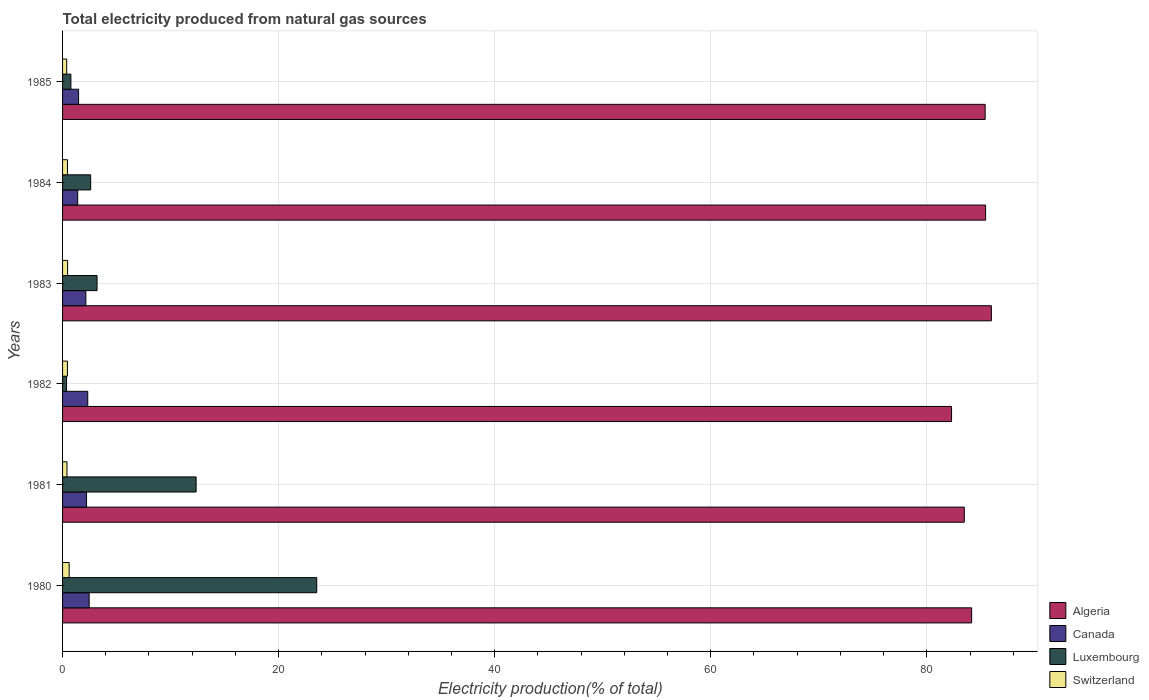How many different coloured bars are there?
Provide a short and direct response. 4. How many groups of bars are there?
Offer a very short reply. 6. Are the number of bars per tick equal to the number of legend labels?
Provide a short and direct response. Yes. Are the number of bars on each tick of the Y-axis equal?
Offer a terse response. Yes. How many bars are there on the 1st tick from the top?
Ensure brevity in your answer.  4. How many bars are there on the 4th tick from the bottom?
Your response must be concise. 4. What is the total electricity produced in Algeria in 1984?
Offer a terse response. 85.44. Across all years, what is the maximum total electricity produced in Canada?
Provide a short and direct response. 2.46. Across all years, what is the minimum total electricity produced in Switzerland?
Offer a very short reply. 0.38. What is the total total electricity produced in Switzerland in the graph?
Make the answer very short. 2.77. What is the difference between the total electricity produced in Luxembourg in 1980 and that in 1983?
Make the answer very short. 20.34. What is the difference between the total electricity produced in Luxembourg in 1985 and the total electricity produced in Switzerland in 1984?
Your response must be concise. 0.32. What is the average total electricity produced in Luxembourg per year?
Ensure brevity in your answer.  7.14. In the year 1980, what is the difference between the total electricity produced in Canada and total electricity produced in Switzerland?
Your answer should be compact. 1.85. In how many years, is the total electricity produced in Canada greater than 4 %?
Ensure brevity in your answer.  0. What is the ratio of the total electricity produced in Switzerland in 1980 to that in 1981?
Offer a terse response. 1.49. Is the difference between the total electricity produced in Canada in 1981 and 1982 greater than the difference between the total electricity produced in Switzerland in 1981 and 1982?
Your response must be concise. No. What is the difference between the highest and the second highest total electricity produced in Switzerland?
Offer a very short reply. 0.14. What is the difference between the highest and the lowest total electricity produced in Algeria?
Provide a succinct answer. 3.69. Is the sum of the total electricity produced in Canada in 1981 and 1984 greater than the maximum total electricity produced in Luxembourg across all years?
Keep it short and to the point. No. What does the 4th bar from the top in 1985 represents?
Your answer should be very brief. Algeria. How many bars are there?
Your answer should be very brief. 24. Does the graph contain any zero values?
Your answer should be compact. No. Where does the legend appear in the graph?
Give a very brief answer. Bottom right. How many legend labels are there?
Provide a short and direct response. 4. How are the legend labels stacked?
Give a very brief answer. Vertical. What is the title of the graph?
Offer a very short reply. Total electricity produced from natural gas sources. What is the Electricity production(% of total) in Algeria in 1980?
Your answer should be very brief. 84.15. What is the Electricity production(% of total) of Canada in 1980?
Offer a terse response. 2.46. What is the Electricity production(% of total) in Luxembourg in 1980?
Offer a terse response. 23.53. What is the Electricity production(% of total) in Switzerland in 1980?
Provide a succinct answer. 0.61. What is the Electricity production(% of total) of Algeria in 1981?
Your answer should be very brief. 83.47. What is the Electricity production(% of total) in Canada in 1981?
Ensure brevity in your answer.  2.22. What is the Electricity production(% of total) in Luxembourg in 1981?
Your answer should be compact. 12.36. What is the Electricity production(% of total) in Switzerland in 1981?
Ensure brevity in your answer.  0.41. What is the Electricity production(% of total) of Algeria in 1982?
Offer a terse response. 82.29. What is the Electricity production(% of total) in Canada in 1982?
Give a very brief answer. 2.33. What is the Electricity production(% of total) in Luxembourg in 1982?
Give a very brief answer. 0.37. What is the Electricity production(% of total) of Switzerland in 1982?
Your answer should be compact. 0.45. What is the Electricity production(% of total) of Algeria in 1983?
Your response must be concise. 85.98. What is the Electricity production(% of total) of Canada in 1983?
Keep it short and to the point. 2.16. What is the Electricity production(% of total) in Luxembourg in 1983?
Offer a very short reply. 3.19. What is the Electricity production(% of total) of Switzerland in 1983?
Provide a short and direct response. 0.47. What is the Electricity production(% of total) in Algeria in 1984?
Give a very brief answer. 85.44. What is the Electricity production(% of total) of Canada in 1984?
Your answer should be very brief. 1.4. What is the Electricity production(% of total) in Luxembourg in 1984?
Give a very brief answer. 2.6. What is the Electricity production(% of total) in Switzerland in 1984?
Your response must be concise. 0.45. What is the Electricity production(% of total) in Algeria in 1985?
Your response must be concise. 85.4. What is the Electricity production(% of total) in Canada in 1985?
Your answer should be compact. 1.48. What is the Electricity production(% of total) in Luxembourg in 1985?
Keep it short and to the point. 0.77. What is the Electricity production(% of total) of Switzerland in 1985?
Provide a succinct answer. 0.38. Across all years, what is the maximum Electricity production(% of total) in Algeria?
Give a very brief answer. 85.98. Across all years, what is the maximum Electricity production(% of total) in Canada?
Make the answer very short. 2.46. Across all years, what is the maximum Electricity production(% of total) in Luxembourg?
Provide a short and direct response. 23.53. Across all years, what is the maximum Electricity production(% of total) of Switzerland?
Make the answer very short. 0.61. Across all years, what is the minimum Electricity production(% of total) of Algeria?
Keep it short and to the point. 82.29. Across all years, what is the minimum Electricity production(% of total) in Canada?
Offer a terse response. 1.4. Across all years, what is the minimum Electricity production(% of total) of Luxembourg?
Ensure brevity in your answer.  0.37. Across all years, what is the minimum Electricity production(% of total) in Switzerland?
Your answer should be very brief. 0.38. What is the total Electricity production(% of total) of Algeria in the graph?
Ensure brevity in your answer.  506.73. What is the total Electricity production(% of total) of Canada in the graph?
Provide a short and direct response. 12.05. What is the total Electricity production(% of total) in Luxembourg in the graph?
Make the answer very short. 42.83. What is the total Electricity production(% of total) of Switzerland in the graph?
Ensure brevity in your answer.  2.77. What is the difference between the Electricity production(% of total) of Algeria in 1980 and that in 1981?
Your answer should be compact. 0.68. What is the difference between the Electricity production(% of total) of Canada in 1980 and that in 1981?
Keep it short and to the point. 0.24. What is the difference between the Electricity production(% of total) of Luxembourg in 1980 and that in 1981?
Your response must be concise. 11.17. What is the difference between the Electricity production(% of total) of Switzerland in 1980 and that in 1981?
Your answer should be very brief. 0.2. What is the difference between the Electricity production(% of total) in Algeria in 1980 and that in 1982?
Give a very brief answer. 1.86. What is the difference between the Electricity production(% of total) of Canada in 1980 and that in 1982?
Your answer should be very brief. 0.13. What is the difference between the Electricity production(% of total) in Luxembourg in 1980 and that in 1982?
Offer a very short reply. 23.16. What is the difference between the Electricity production(% of total) in Switzerland in 1980 and that in 1982?
Keep it short and to the point. 0.16. What is the difference between the Electricity production(% of total) in Algeria in 1980 and that in 1983?
Provide a short and direct response. -1.83. What is the difference between the Electricity production(% of total) in Canada in 1980 and that in 1983?
Provide a short and direct response. 0.31. What is the difference between the Electricity production(% of total) of Luxembourg in 1980 and that in 1983?
Make the answer very short. 20.34. What is the difference between the Electricity production(% of total) of Switzerland in 1980 and that in 1983?
Give a very brief answer. 0.14. What is the difference between the Electricity production(% of total) of Algeria in 1980 and that in 1984?
Make the answer very short. -1.29. What is the difference between the Electricity production(% of total) of Canada in 1980 and that in 1984?
Your response must be concise. 1.06. What is the difference between the Electricity production(% of total) of Luxembourg in 1980 and that in 1984?
Keep it short and to the point. 20.93. What is the difference between the Electricity production(% of total) of Switzerland in 1980 and that in 1984?
Provide a short and direct response. 0.16. What is the difference between the Electricity production(% of total) of Algeria in 1980 and that in 1985?
Your answer should be very brief. -1.25. What is the difference between the Electricity production(% of total) in Luxembourg in 1980 and that in 1985?
Your answer should be compact. 22.76. What is the difference between the Electricity production(% of total) in Switzerland in 1980 and that in 1985?
Offer a terse response. 0.23. What is the difference between the Electricity production(% of total) in Algeria in 1981 and that in 1982?
Keep it short and to the point. 1.18. What is the difference between the Electricity production(% of total) of Canada in 1981 and that in 1982?
Ensure brevity in your answer.  -0.11. What is the difference between the Electricity production(% of total) of Luxembourg in 1981 and that in 1982?
Your response must be concise. 11.99. What is the difference between the Electricity production(% of total) of Switzerland in 1981 and that in 1982?
Keep it short and to the point. -0.04. What is the difference between the Electricity production(% of total) in Algeria in 1981 and that in 1983?
Provide a short and direct response. -2.51. What is the difference between the Electricity production(% of total) of Canada in 1981 and that in 1983?
Keep it short and to the point. 0.06. What is the difference between the Electricity production(% of total) in Luxembourg in 1981 and that in 1983?
Give a very brief answer. 9.17. What is the difference between the Electricity production(% of total) in Switzerland in 1981 and that in 1983?
Give a very brief answer. -0.06. What is the difference between the Electricity production(% of total) in Algeria in 1981 and that in 1984?
Your response must be concise. -1.97. What is the difference between the Electricity production(% of total) in Canada in 1981 and that in 1984?
Keep it short and to the point. 0.82. What is the difference between the Electricity production(% of total) of Luxembourg in 1981 and that in 1984?
Make the answer very short. 9.76. What is the difference between the Electricity production(% of total) of Switzerland in 1981 and that in 1984?
Offer a terse response. -0.04. What is the difference between the Electricity production(% of total) of Algeria in 1981 and that in 1985?
Offer a terse response. -1.93. What is the difference between the Electricity production(% of total) in Canada in 1981 and that in 1985?
Keep it short and to the point. 0.74. What is the difference between the Electricity production(% of total) in Luxembourg in 1981 and that in 1985?
Provide a succinct answer. 11.59. What is the difference between the Electricity production(% of total) of Switzerland in 1981 and that in 1985?
Ensure brevity in your answer.  0.03. What is the difference between the Electricity production(% of total) in Algeria in 1982 and that in 1983?
Ensure brevity in your answer.  -3.69. What is the difference between the Electricity production(% of total) of Canada in 1982 and that in 1983?
Offer a very short reply. 0.18. What is the difference between the Electricity production(% of total) of Luxembourg in 1982 and that in 1983?
Ensure brevity in your answer.  -2.82. What is the difference between the Electricity production(% of total) in Switzerland in 1982 and that in 1983?
Your answer should be compact. -0.02. What is the difference between the Electricity production(% of total) of Algeria in 1982 and that in 1984?
Offer a very short reply. -3.15. What is the difference between the Electricity production(% of total) of Canada in 1982 and that in 1984?
Ensure brevity in your answer.  0.93. What is the difference between the Electricity production(% of total) in Luxembourg in 1982 and that in 1984?
Ensure brevity in your answer.  -2.23. What is the difference between the Electricity production(% of total) of Switzerland in 1982 and that in 1984?
Give a very brief answer. -0. What is the difference between the Electricity production(% of total) in Algeria in 1982 and that in 1985?
Make the answer very short. -3.11. What is the difference between the Electricity production(% of total) in Canada in 1982 and that in 1985?
Your answer should be compact. 0.85. What is the difference between the Electricity production(% of total) of Luxembourg in 1982 and that in 1985?
Your response must be concise. -0.4. What is the difference between the Electricity production(% of total) of Switzerland in 1982 and that in 1985?
Ensure brevity in your answer.  0.07. What is the difference between the Electricity production(% of total) of Algeria in 1983 and that in 1984?
Offer a very short reply. 0.53. What is the difference between the Electricity production(% of total) of Canada in 1983 and that in 1984?
Ensure brevity in your answer.  0.76. What is the difference between the Electricity production(% of total) in Luxembourg in 1983 and that in 1984?
Your response must be concise. 0.59. What is the difference between the Electricity production(% of total) in Switzerland in 1983 and that in 1984?
Provide a succinct answer. 0.02. What is the difference between the Electricity production(% of total) of Algeria in 1983 and that in 1985?
Your answer should be compact. 0.58. What is the difference between the Electricity production(% of total) of Canada in 1983 and that in 1985?
Give a very brief answer. 0.67. What is the difference between the Electricity production(% of total) in Luxembourg in 1983 and that in 1985?
Keep it short and to the point. 2.42. What is the difference between the Electricity production(% of total) in Switzerland in 1983 and that in 1985?
Your answer should be compact. 0.08. What is the difference between the Electricity production(% of total) in Algeria in 1984 and that in 1985?
Your answer should be compact. 0.04. What is the difference between the Electricity production(% of total) in Canada in 1984 and that in 1985?
Offer a very short reply. -0.08. What is the difference between the Electricity production(% of total) of Luxembourg in 1984 and that in 1985?
Offer a terse response. 1.83. What is the difference between the Electricity production(% of total) in Switzerland in 1984 and that in 1985?
Make the answer very short. 0.07. What is the difference between the Electricity production(% of total) of Algeria in 1980 and the Electricity production(% of total) of Canada in 1981?
Your answer should be compact. 81.93. What is the difference between the Electricity production(% of total) of Algeria in 1980 and the Electricity production(% of total) of Luxembourg in 1981?
Offer a very short reply. 71.79. What is the difference between the Electricity production(% of total) in Algeria in 1980 and the Electricity production(% of total) in Switzerland in 1981?
Offer a terse response. 83.74. What is the difference between the Electricity production(% of total) of Canada in 1980 and the Electricity production(% of total) of Luxembourg in 1981?
Your answer should be compact. -9.9. What is the difference between the Electricity production(% of total) of Canada in 1980 and the Electricity production(% of total) of Switzerland in 1981?
Provide a short and direct response. 2.05. What is the difference between the Electricity production(% of total) in Luxembourg in 1980 and the Electricity production(% of total) in Switzerland in 1981?
Offer a very short reply. 23.12. What is the difference between the Electricity production(% of total) in Algeria in 1980 and the Electricity production(% of total) in Canada in 1982?
Your answer should be compact. 81.82. What is the difference between the Electricity production(% of total) in Algeria in 1980 and the Electricity production(% of total) in Luxembourg in 1982?
Offer a very short reply. 83.78. What is the difference between the Electricity production(% of total) in Algeria in 1980 and the Electricity production(% of total) in Switzerland in 1982?
Keep it short and to the point. 83.7. What is the difference between the Electricity production(% of total) of Canada in 1980 and the Electricity production(% of total) of Luxembourg in 1982?
Ensure brevity in your answer.  2.09. What is the difference between the Electricity production(% of total) in Canada in 1980 and the Electricity production(% of total) in Switzerland in 1982?
Your answer should be very brief. 2.01. What is the difference between the Electricity production(% of total) of Luxembourg in 1980 and the Electricity production(% of total) of Switzerland in 1982?
Keep it short and to the point. 23.08. What is the difference between the Electricity production(% of total) in Algeria in 1980 and the Electricity production(% of total) in Canada in 1983?
Your response must be concise. 81.99. What is the difference between the Electricity production(% of total) of Algeria in 1980 and the Electricity production(% of total) of Luxembourg in 1983?
Make the answer very short. 80.96. What is the difference between the Electricity production(% of total) in Algeria in 1980 and the Electricity production(% of total) in Switzerland in 1983?
Give a very brief answer. 83.68. What is the difference between the Electricity production(% of total) in Canada in 1980 and the Electricity production(% of total) in Luxembourg in 1983?
Provide a succinct answer. -0.73. What is the difference between the Electricity production(% of total) of Canada in 1980 and the Electricity production(% of total) of Switzerland in 1983?
Ensure brevity in your answer.  2. What is the difference between the Electricity production(% of total) in Luxembourg in 1980 and the Electricity production(% of total) in Switzerland in 1983?
Ensure brevity in your answer.  23.06. What is the difference between the Electricity production(% of total) in Algeria in 1980 and the Electricity production(% of total) in Canada in 1984?
Keep it short and to the point. 82.75. What is the difference between the Electricity production(% of total) of Algeria in 1980 and the Electricity production(% of total) of Luxembourg in 1984?
Offer a very short reply. 81.55. What is the difference between the Electricity production(% of total) in Algeria in 1980 and the Electricity production(% of total) in Switzerland in 1984?
Your response must be concise. 83.7. What is the difference between the Electricity production(% of total) of Canada in 1980 and the Electricity production(% of total) of Luxembourg in 1984?
Your response must be concise. -0.14. What is the difference between the Electricity production(% of total) of Canada in 1980 and the Electricity production(% of total) of Switzerland in 1984?
Offer a terse response. 2.01. What is the difference between the Electricity production(% of total) in Luxembourg in 1980 and the Electricity production(% of total) in Switzerland in 1984?
Your answer should be very brief. 23.08. What is the difference between the Electricity production(% of total) of Algeria in 1980 and the Electricity production(% of total) of Canada in 1985?
Keep it short and to the point. 82.67. What is the difference between the Electricity production(% of total) of Algeria in 1980 and the Electricity production(% of total) of Luxembourg in 1985?
Your answer should be compact. 83.38. What is the difference between the Electricity production(% of total) of Algeria in 1980 and the Electricity production(% of total) of Switzerland in 1985?
Give a very brief answer. 83.77. What is the difference between the Electricity production(% of total) in Canada in 1980 and the Electricity production(% of total) in Luxembourg in 1985?
Keep it short and to the point. 1.69. What is the difference between the Electricity production(% of total) in Canada in 1980 and the Electricity production(% of total) in Switzerland in 1985?
Provide a succinct answer. 2.08. What is the difference between the Electricity production(% of total) in Luxembourg in 1980 and the Electricity production(% of total) in Switzerland in 1985?
Offer a very short reply. 23.15. What is the difference between the Electricity production(% of total) in Algeria in 1981 and the Electricity production(% of total) in Canada in 1982?
Your answer should be very brief. 81.14. What is the difference between the Electricity production(% of total) in Algeria in 1981 and the Electricity production(% of total) in Luxembourg in 1982?
Give a very brief answer. 83.1. What is the difference between the Electricity production(% of total) in Algeria in 1981 and the Electricity production(% of total) in Switzerland in 1982?
Offer a very short reply. 83.02. What is the difference between the Electricity production(% of total) in Canada in 1981 and the Electricity production(% of total) in Luxembourg in 1982?
Ensure brevity in your answer.  1.85. What is the difference between the Electricity production(% of total) in Canada in 1981 and the Electricity production(% of total) in Switzerland in 1982?
Provide a short and direct response. 1.77. What is the difference between the Electricity production(% of total) in Luxembourg in 1981 and the Electricity production(% of total) in Switzerland in 1982?
Make the answer very short. 11.91. What is the difference between the Electricity production(% of total) of Algeria in 1981 and the Electricity production(% of total) of Canada in 1983?
Your response must be concise. 81.31. What is the difference between the Electricity production(% of total) of Algeria in 1981 and the Electricity production(% of total) of Luxembourg in 1983?
Give a very brief answer. 80.28. What is the difference between the Electricity production(% of total) of Algeria in 1981 and the Electricity production(% of total) of Switzerland in 1983?
Your answer should be very brief. 83. What is the difference between the Electricity production(% of total) of Canada in 1981 and the Electricity production(% of total) of Luxembourg in 1983?
Offer a terse response. -0.97. What is the difference between the Electricity production(% of total) of Canada in 1981 and the Electricity production(% of total) of Switzerland in 1983?
Ensure brevity in your answer.  1.75. What is the difference between the Electricity production(% of total) of Luxembourg in 1981 and the Electricity production(% of total) of Switzerland in 1983?
Ensure brevity in your answer.  11.9. What is the difference between the Electricity production(% of total) in Algeria in 1981 and the Electricity production(% of total) in Canada in 1984?
Your answer should be very brief. 82.07. What is the difference between the Electricity production(% of total) in Algeria in 1981 and the Electricity production(% of total) in Luxembourg in 1984?
Your answer should be compact. 80.87. What is the difference between the Electricity production(% of total) in Algeria in 1981 and the Electricity production(% of total) in Switzerland in 1984?
Offer a very short reply. 83.02. What is the difference between the Electricity production(% of total) of Canada in 1981 and the Electricity production(% of total) of Luxembourg in 1984?
Provide a short and direct response. -0.38. What is the difference between the Electricity production(% of total) in Canada in 1981 and the Electricity production(% of total) in Switzerland in 1984?
Your answer should be compact. 1.77. What is the difference between the Electricity production(% of total) of Luxembourg in 1981 and the Electricity production(% of total) of Switzerland in 1984?
Your answer should be compact. 11.91. What is the difference between the Electricity production(% of total) in Algeria in 1981 and the Electricity production(% of total) in Canada in 1985?
Offer a very short reply. 81.98. What is the difference between the Electricity production(% of total) in Algeria in 1981 and the Electricity production(% of total) in Luxembourg in 1985?
Give a very brief answer. 82.7. What is the difference between the Electricity production(% of total) of Algeria in 1981 and the Electricity production(% of total) of Switzerland in 1985?
Your response must be concise. 83.08. What is the difference between the Electricity production(% of total) of Canada in 1981 and the Electricity production(% of total) of Luxembourg in 1985?
Make the answer very short. 1.45. What is the difference between the Electricity production(% of total) of Canada in 1981 and the Electricity production(% of total) of Switzerland in 1985?
Give a very brief answer. 1.84. What is the difference between the Electricity production(% of total) in Luxembourg in 1981 and the Electricity production(% of total) in Switzerland in 1985?
Your response must be concise. 11.98. What is the difference between the Electricity production(% of total) of Algeria in 1982 and the Electricity production(% of total) of Canada in 1983?
Your answer should be very brief. 80.13. What is the difference between the Electricity production(% of total) of Algeria in 1982 and the Electricity production(% of total) of Luxembourg in 1983?
Offer a very short reply. 79.1. What is the difference between the Electricity production(% of total) of Algeria in 1982 and the Electricity production(% of total) of Switzerland in 1983?
Ensure brevity in your answer.  81.82. What is the difference between the Electricity production(% of total) in Canada in 1982 and the Electricity production(% of total) in Luxembourg in 1983?
Give a very brief answer. -0.86. What is the difference between the Electricity production(% of total) in Canada in 1982 and the Electricity production(% of total) in Switzerland in 1983?
Provide a short and direct response. 1.86. What is the difference between the Electricity production(% of total) in Luxembourg in 1982 and the Electricity production(% of total) in Switzerland in 1983?
Provide a succinct answer. -0.1. What is the difference between the Electricity production(% of total) of Algeria in 1982 and the Electricity production(% of total) of Canada in 1984?
Offer a terse response. 80.89. What is the difference between the Electricity production(% of total) of Algeria in 1982 and the Electricity production(% of total) of Luxembourg in 1984?
Make the answer very short. 79.69. What is the difference between the Electricity production(% of total) in Algeria in 1982 and the Electricity production(% of total) in Switzerland in 1984?
Your answer should be very brief. 81.84. What is the difference between the Electricity production(% of total) of Canada in 1982 and the Electricity production(% of total) of Luxembourg in 1984?
Your response must be concise. -0.27. What is the difference between the Electricity production(% of total) of Canada in 1982 and the Electricity production(% of total) of Switzerland in 1984?
Offer a terse response. 1.88. What is the difference between the Electricity production(% of total) in Luxembourg in 1982 and the Electricity production(% of total) in Switzerland in 1984?
Make the answer very short. -0.08. What is the difference between the Electricity production(% of total) in Algeria in 1982 and the Electricity production(% of total) in Canada in 1985?
Your answer should be compact. 80.81. What is the difference between the Electricity production(% of total) in Algeria in 1982 and the Electricity production(% of total) in Luxembourg in 1985?
Ensure brevity in your answer.  81.52. What is the difference between the Electricity production(% of total) of Algeria in 1982 and the Electricity production(% of total) of Switzerland in 1985?
Give a very brief answer. 81.91. What is the difference between the Electricity production(% of total) of Canada in 1982 and the Electricity production(% of total) of Luxembourg in 1985?
Provide a succinct answer. 1.56. What is the difference between the Electricity production(% of total) of Canada in 1982 and the Electricity production(% of total) of Switzerland in 1985?
Provide a succinct answer. 1.95. What is the difference between the Electricity production(% of total) of Luxembourg in 1982 and the Electricity production(% of total) of Switzerland in 1985?
Provide a succinct answer. -0.01. What is the difference between the Electricity production(% of total) in Algeria in 1983 and the Electricity production(% of total) in Canada in 1984?
Your answer should be very brief. 84.58. What is the difference between the Electricity production(% of total) of Algeria in 1983 and the Electricity production(% of total) of Luxembourg in 1984?
Make the answer very short. 83.37. What is the difference between the Electricity production(% of total) in Algeria in 1983 and the Electricity production(% of total) in Switzerland in 1984?
Give a very brief answer. 85.52. What is the difference between the Electricity production(% of total) of Canada in 1983 and the Electricity production(% of total) of Luxembourg in 1984?
Offer a very short reply. -0.45. What is the difference between the Electricity production(% of total) in Canada in 1983 and the Electricity production(% of total) in Switzerland in 1984?
Give a very brief answer. 1.7. What is the difference between the Electricity production(% of total) of Luxembourg in 1983 and the Electricity production(% of total) of Switzerland in 1984?
Give a very brief answer. 2.74. What is the difference between the Electricity production(% of total) of Algeria in 1983 and the Electricity production(% of total) of Canada in 1985?
Keep it short and to the point. 84.49. What is the difference between the Electricity production(% of total) of Algeria in 1983 and the Electricity production(% of total) of Luxembourg in 1985?
Ensure brevity in your answer.  85.2. What is the difference between the Electricity production(% of total) in Algeria in 1983 and the Electricity production(% of total) in Switzerland in 1985?
Provide a succinct answer. 85.59. What is the difference between the Electricity production(% of total) of Canada in 1983 and the Electricity production(% of total) of Luxembourg in 1985?
Offer a very short reply. 1.39. What is the difference between the Electricity production(% of total) of Canada in 1983 and the Electricity production(% of total) of Switzerland in 1985?
Your response must be concise. 1.77. What is the difference between the Electricity production(% of total) of Luxembourg in 1983 and the Electricity production(% of total) of Switzerland in 1985?
Your answer should be very brief. 2.81. What is the difference between the Electricity production(% of total) of Algeria in 1984 and the Electricity production(% of total) of Canada in 1985?
Offer a terse response. 83.96. What is the difference between the Electricity production(% of total) of Algeria in 1984 and the Electricity production(% of total) of Luxembourg in 1985?
Provide a succinct answer. 84.67. What is the difference between the Electricity production(% of total) in Algeria in 1984 and the Electricity production(% of total) in Switzerland in 1985?
Give a very brief answer. 85.06. What is the difference between the Electricity production(% of total) of Canada in 1984 and the Electricity production(% of total) of Luxembourg in 1985?
Keep it short and to the point. 0.63. What is the difference between the Electricity production(% of total) of Canada in 1984 and the Electricity production(% of total) of Switzerland in 1985?
Your response must be concise. 1.02. What is the difference between the Electricity production(% of total) in Luxembourg in 1984 and the Electricity production(% of total) in Switzerland in 1985?
Ensure brevity in your answer.  2.22. What is the average Electricity production(% of total) of Algeria per year?
Your response must be concise. 84.45. What is the average Electricity production(% of total) of Canada per year?
Offer a terse response. 2.01. What is the average Electricity production(% of total) in Luxembourg per year?
Ensure brevity in your answer.  7.14. What is the average Electricity production(% of total) of Switzerland per year?
Your answer should be compact. 0.46. In the year 1980, what is the difference between the Electricity production(% of total) of Algeria and Electricity production(% of total) of Canada?
Your answer should be compact. 81.69. In the year 1980, what is the difference between the Electricity production(% of total) in Algeria and Electricity production(% of total) in Luxembourg?
Keep it short and to the point. 60.62. In the year 1980, what is the difference between the Electricity production(% of total) in Algeria and Electricity production(% of total) in Switzerland?
Offer a very short reply. 83.54. In the year 1980, what is the difference between the Electricity production(% of total) in Canada and Electricity production(% of total) in Luxembourg?
Your response must be concise. -21.07. In the year 1980, what is the difference between the Electricity production(% of total) in Canada and Electricity production(% of total) in Switzerland?
Your response must be concise. 1.85. In the year 1980, what is the difference between the Electricity production(% of total) of Luxembourg and Electricity production(% of total) of Switzerland?
Your answer should be very brief. 22.92. In the year 1981, what is the difference between the Electricity production(% of total) in Algeria and Electricity production(% of total) in Canada?
Make the answer very short. 81.25. In the year 1981, what is the difference between the Electricity production(% of total) of Algeria and Electricity production(% of total) of Luxembourg?
Your answer should be very brief. 71.11. In the year 1981, what is the difference between the Electricity production(% of total) of Algeria and Electricity production(% of total) of Switzerland?
Give a very brief answer. 83.06. In the year 1981, what is the difference between the Electricity production(% of total) in Canada and Electricity production(% of total) in Luxembourg?
Your answer should be very brief. -10.14. In the year 1981, what is the difference between the Electricity production(% of total) in Canada and Electricity production(% of total) in Switzerland?
Ensure brevity in your answer.  1.81. In the year 1981, what is the difference between the Electricity production(% of total) in Luxembourg and Electricity production(% of total) in Switzerland?
Make the answer very short. 11.95. In the year 1982, what is the difference between the Electricity production(% of total) of Algeria and Electricity production(% of total) of Canada?
Provide a succinct answer. 79.96. In the year 1982, what is the difference between the Electricity production(% of total) in Algeria and Electricity production(% of total) in Luxembourg?
Give a very brief answer. 81.92. In the year 1982, what is the difference between the Electricity production(% of total) of Algeria and Electricity production(% of total) of Switzerland?
Ensure brevity in your answer.  81.84. In the year 1982, what is the difference between the Electricity production(% of total) of Canada and Electricity production(% of total) of Luxembourg?
Keep it short and to the point. 1.96. In the year 1982, what is the difference between the Electricity production(% of total) of Canada and Electricity production(% of total) of Switzerland?
Your answer should be very brief. 1.88. In the year 1982, what is the difference between the Electricity production(% of total) of Luxembourg and Electricity production(% of total) of Switzerland?
Give a very brief answer. -0.08. In the year 1983, what is the difference between the Electricity production(% of total) of Algeria and Electricity production(% of total) of Canada?
Ensure brevity in your answer.  83.82. In the year 1983, what is the difference between the Electricity production(% of total) in Algeria and Electricity production(% of total) in Luxembourg?
Your answer should be compact. 82.78. In the year 1983, what is the difference between the Electricity production(% of total) in Algeria and Electricity production(% of total) in Switzerland?
Make the answer very short. 85.51. In the year 1983, what is the difference between the Electricity production(% of total) of Canada and Electricity production(% of total) of Luxembourg?
Make the answer very short. -1.04. In the year 1983, what is the difference between the Electricity production(% of total) of Canada and Electricity production(% of total) of Switzerland?
Make the answer very short. 1.69. In the year 1983, what is the difference between the Electricity production(% of total) of Luxembourg and Electricity production(% of total) of Switzerland?
Your answer should be compact. 2.72. In the year 1984, what is the difference between the Electricity production(% of total) in Algeria and Electricity production(% of total) in Canada?
Your response must be concise. 84.04. In the year 1984, what is the difference between the Electricity production(% of total) of Algeria and Electricity production(% of total) of Luxembourg?
Your answer should be compact. 82.84. In the year 1984, what is the difference between the Electricity production(% of total) in Algeria and Electricity production(% of total) in Switzerland?
Keep it short and to the point. 84.99. In the year 1984, what is the difference between the Electricity production(% of total) in Canada and Electricity production(% of total) in Luxembourg?
Offer a very short reply. -1.2. In the year 1984, what is the difference between the Electricity production(% of total) in Canada and Electricity production(% of total) in Switzerland?
Offer a very short reply. 0.95. In the year 1984, what is the difference between the Electricity production(% of total) of Luxembourg and Electricity production(% of total) of Switzerland?
Offer a terse response. 2.15. In the year 1985, what is the difference between the Electricity production(% of total) of Algeria and Electricity production(% of total) of Canada?
Offer a very short reply. 83.92. In the year 1985, what is the difference between the Electricity production(% of total) of Algeria and Electricity production(% of total) of Luxembourg?
Keep it short and to the point. 84.63. In the year 1985, what is the difference between the Electricity production(% of total) of Algeria and Electricity production(% of total) of Switzerland?
Offer a very short reply. 85.02. In the year 1985, what is the difference between the Electricity production(% of total) in Canada and Electricity production(% of total) in Luxembourg?
Provide a succinct answer. 0.71. In the year 1985, what is the difference between the Electricity production(% of total) in Luxembourg and Electricity production(% of total) in Switzerland?
Keep it short and to the point. 0.39. What is the ratio of the Electricity production(% of total) in Algeria in 1980 to that in 1981?
Offer a very short reply. 1.01. What is the ratio of the Electricity production(% of total) of Canada in 1980 to that in 1981?
Make the answer very short. 1.11. What is the ratio of the Electricity production(% of total) of Luxembourg in 1980 to that in 1981?
Ensure brevity in your answer.  1.9. What is the ratio of the Electricity production(% of total) of Switzerland in 1980 to that in 1981?
Your response must be concise. 1.49. What is the ratio of the Electricity production(% of total) of Algeria in 1980 to that in 1982?
Make the answer very short. 1.02. What is the ratio of the Electricity production(% of total) of Canada in 1980 to that in 1982?
Give a very brief answer. 1.06. What is the ratio of the Electricity production(% of total) in Luxembourg in 1980 to that in 1982?
Your answer should be compact. 63.76. What is the ratio of the Electricity production(% of total) of Switzerland in 1980 to that in 1982?
Provide a succinct answer. 1.35. What is the ratio of the Electricity production(% of total) in Algeria in 1980 to that in 1983?
Your response must be concise. 0.98. What is the ratio of the Electricity production(% of total) of Canada in 1980 to that in 1983?
Your answer should be compact. 1.14. What is the ratio of the Electricity production(% of total) of Luxembourg in 1980 to that in 1983?
Make the answer very short. 7.37. What is the ratio of the Electricity production(% of total) of Switzerland in 1980 to that in 1983?
Keep it short and to the point. 1.31. What is the ratio of the Electricity production(% of total) in Algeria in 1980 to that in 1984?
Provide a succinct answer. 0.98. What is the ratio of the Electricity production(% of total) in Canada in 1980 to that in 1984?
Make the answer very short. 1.76. What is the ratio of the Electricity production(% of total) in Luxembourg in 1980 to that in 1984?
Make the answer very short. 9.04. What is the ratio of the Electricity production(% of total) in Switzerland in 1980 to that in 1984?
Keep it short and to the point. 1.35. What is the ratio of the Electricity production(% of total) of Algeria in 1980 to that in 1985?
Provide a short and direct response. 0.99. What is the ratio of the Electricity production(% of total) of Canada in 1980 to that in 1985?
Your response must be concise. 1.66. What is the ratio of the Electricity production(% of total) in Luxembourg in 1980 to that in 1985?
Offer a terse response. 30.53. What is the ratio of the Electricity production(% of total) of Switzerland in 1980 to that in 1985?
Keep it short and to the point. 1.59. What is the ratio of the Electricity production(% of total) in Algeria in 1981 to that in 1982?
Offer a terse response. 1.01. What is the ratio of the Electricity production(% of total) in Canada in 1981 to that in 1982?
Offer a very short reply. 0.95. What is the ratio of the Electricity production(% of total) of Luxembourg in 1981 to that in 1982?
Keep it short and to the point. 33.5. What is the ratio of the Electricity production(% of total) of Switzerland in 1981 to that in 1982?
Offer a terse response. 0.91. What is the ratio of the Electricity production(% of total) of Algeria in 1981 to that in 1983?
Give a very brief answer. 0.97. What is the ratio of the Electricity production(% of total) of Canada in 1981 to that in 1983?
Your answer should be very brief. 1.03. What is the ratio of the Electricity production(% of total) of Luxembourg in 1981 to that in 1983?
Make the answer very short. 3.87. What is the ratio of the Electricity production(% of total) of Switzerland in 1981 to that in 1983?
Give a very brief answer. 0.87. What is the ratio of the Electricity production(% of total) of Algeria in 1981 to that in 1984?
Keep it short and to the point. 0.98. What is the ratio of the Electricity production(% of total) in Canada in 1981 to that in 1984?
Your response must be concise. 1.59. What is the ratio of the Electricity production(% of total) of Luxembourg in 1981 to that in 1984?
Provide a succinct answer. 4.75. What is the ratio of the Electricity production(% of total) in Switzerland in 1981 to that in 1984?
Your response must be concise. 0.9. What is the ratio of the Electricity production(% of total) of Algeria in 1981 to that in 1985?
Your answer should be very brief. 0.98. What is the ratio of the Electricity production(% of total) of Canada in 1981 to that in 1985?
Provide a short and direct response. 1.5. What is the ratio of the Electricity production(% of total) of Luxembourg in 1981 to that in 1985?
Provide a short and direct response. 16.04. What is the ratio of the Electricity production(% of total) of Switzerland in 1981 to that in 1985?
Ensure brevity in your answer.  1.07. What is the ratio of the Electricity production(% of total) of Algeria in 1982 to that in 1983?
Your response must be concise. 0.96. What is the ratio of the Electricity production(% of total) in Canada in 1982 to that in 1983?
Give a very brief answer. 1.08. What is the ratio of the Electricity production(% of total) in Luxembourg in 1982 to that in 1983?
Offer a terse response. 0.12. What is the ratio of the Electricity production(% of total) in Switzerland in 1982 to that in 1983?
Your response must be concise. 0.97. What is the ratio of the Electricity production(% of total) of Algeria in 1982 to that in 1984?
Offer a terse response. 0.96. What is the ratio of the Electricity production(% of total) of Canada in 1982 to that in 1984?
Offer a very short reply. 1.66. What is the ratio of the Electricity production(% of total) in Luxembourg in 1982 to that in 1984?
Your answer should be compact. 0.14. What is the ratio of the Electricity production(% of total) of Algeria in 1982 to that in 1985?
Keep it short and to the point. 0.96. What is the ratio of the Electricity production(% of total) in Canada in 1982 to that in 1985?
Your answer should be compact. 1.57. What is the ratio of the Electricity production(% of total) in Luxembourg in 1982 to that in 1985?
Make the answer very short. 0.48. What is the ratio of the Electricity production(% of total) of Switzerland in 1982 to that in 1985?
Offer a terse response. 1.18. What is the ratio of the Electricity production(% of total) of Algeria in 1983 to that in 1984?
Offer a very short reply. 1.01. What is the ratio of the Electricity production(% of total) of Canada in 1983 to that in 1984?
Keep it short and to the point. 1.54. What is the ratio of the Electricity production(% of total) in Luxembourg in 1983 to that in 1984?
Keep it short and to the point. 1.23. What is the ratio of the Electricity production(% of total) in Switzerland in 1983 to that in 1984?
Provide a succinct answer. 1.03. What is the ratio of the Electricity production(% of total) in Canada in 1983 to that in 1985?
Keep it short and to the point. 1.45. What is the ratio of the Electricity production(% of total) of Luxembourg in 1983 to that in 1985?
Offer a very short reply. 4.14. What is the ratio of the Electricity production(% of total) in Switzerland in 1983 to that in 1985?
Your response must be concise. 1.22. What is the ratio of the Electricity production(% of total) of Algeria in 1984 to that in 1985?
Your answer should be compact. 1. What is the ratio of the Electricity production(% of total) of Canada in 1984 to that in 1985?
Your answer should be compact. 0.94. What is the ratio of the Electricity production(% of total) in Luxembourg in 1984 to that in 1985?
Keep it short and to the point. 3.38. What is the ratio of the Electricity production(% of total) in Switzerland in 1984 to that in 1985?
Ensure brevity in your answer.  1.18. What is the difference between the highest and the second highest Electricity production(% of total) in Algeria?
Make the answer very short. 0.53. What is the difference between the highest and the second highest Electricity production(% of total) in Canada?
Make the answer very short. 0.13. What is the difference between the highest and the second highest Electricity production(% of total) of Luxembourg?
Your answer should be very brief. 11.17. What is the difference between the highest and the second highest Electricity production(% of total) of Switzerland?
Offer a very short reply. 0.14. What is the difference between the highest and the lowest Electricity production(% of total) of Algeria?
Your answer should be compact. 3.69. What is the difference between the highest and the lowest Electricity production(% of total) in Canada?
Offer a very short reply. 1.06. What is the difference between the highest and the lowest Electricity production(% of total) in Luxembourg?
Offer a terse response. 23.16. What is the difference between the highest and the lowest Electricity production(% of total) in Switzerland?
Offer a terse response. 0.23. 